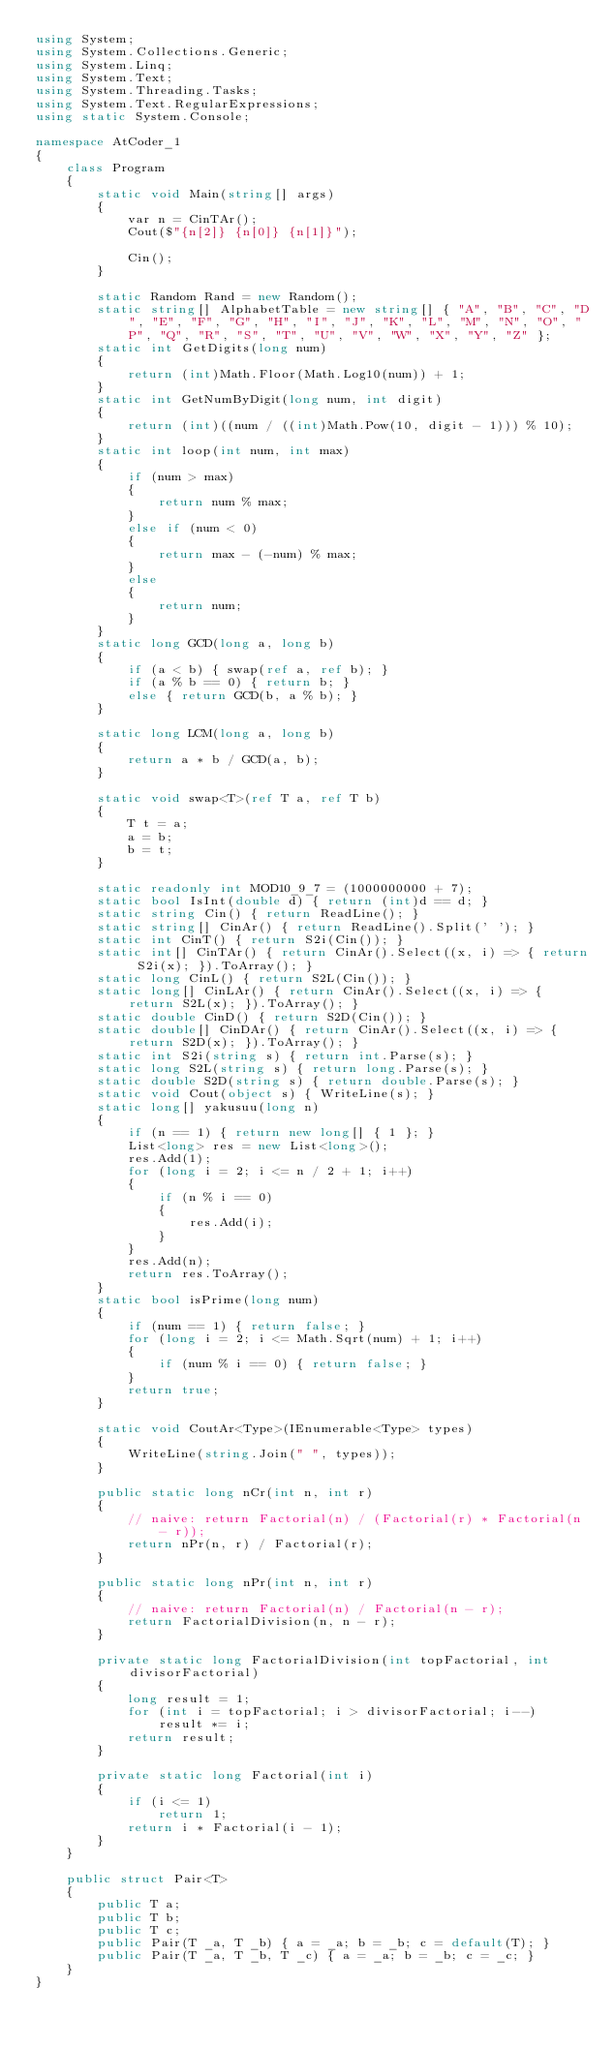<code> <loc_0><loc_0><loc_500><loc_500><_C#_>using System;
using System.Collections.Generic;
using System.Linq;
using System.Text;
using System.Threading.Tasks;
using System.Text.RegularExpressions;
using static System.Console;

namespace AtCoder_1
{
    class Program
    {
        static void Main(string[] args)
        {
            var n = CinTAr();
            Cout($"{n[2]} {n[0]} {n[1]}");

            Cin();
        }

        static Random Rand = new Random();
        static string[] AlphabetTable = new string[] { "A", "B", "C", "D", "E", "F", "G", "H", "I", "J", "K", "L", "M", "N", "O", "P", "Q", "R", "S", "T", "U", "V", "W", "X", "Y", "Z" };
        static int GetDigits(long num)
        {
            return (int)Math.Floor(Math.Log10(num)) + 1;
        }
        static int GetNumByDigit(long num, int digit)
        {
            return (int)((num / ((int)Math.Pow(10, digit - 1))) % 10);
        }
        static int loop(int num, int max)
        {
            if (num > max)
            {
                return num % max;
            }
            else if (num < 0)
            {
                return max - (-num) % max;
            }
            else
            {
                return num;
            }
        }
        static long GCD(long a, long b)
        {
            if (a < b) { swap(ref a, ref b); }
            if (a % b == 0) { return b; }
            else { return GCD(b, a % b); }
        }

        static long LCM(long a, long b)
        {
            return a * b / GCD(a, b);
        }

        static void swap<T>(ref T a, ref T b)
        {
            T t = a;
            a = b;
            b = t;
        }

        static readonly int MOD10_9_7 = (1000000000 + 7);
        static bool IsInt(double d) { return (int)d == d; }
        static string Cin() { return ReadLine(); }
        static string[] CinAr() { return ReadLine().Split(' '); }
        static int CinT() { return S2i(Cin()); }
        static int[] CinTAr() { return CinAr().Select((x, i) => { return S2i(x); }).ToArray(); }
        static long CinL() { return S2L(Cin()); }
        static long[] CinLAr() { return CinAr().Select((x, i) => { return S2L(x); }).ToArray(); }
        static double CinD() { return S2D(Cin()); }
        static double[] CinDAr() { return CinAr().Select((x, i) => { return S2D(x); }).ToArray(); }
        static int S2i(string s) { return int.Parse(s); }
        static long S2L(string s) { return long.Parse(s); }
        static double S2D(string s) { return double.Parse(s); }
        static void Cout(object s) { WriteLine(s); }
        static long[] yakusuu(long n)
        {
            if (n == 1) { return new long[] { 1 }; }
            List<long> res = new List<long>();
            res.Add(1);
            for (long i = 2; i <= n / 2 + 1; i++)
            {
                if (n % i == 0)
                {
                    res.Add(i);
                }
            }
            res.Add(n);
            return res.ToArray();
        }
        static bool isPrime(long num)
        {
            if (num == 1) { return false; }
            for (long i = 2; i <= Math.Sqrt(num) + 1; i++)
            {
                if (num % i == 0) { return false; }
            }
            return true;
        }

        static void CoutAr<Type>(IEnumerable<Type> types)
        {
            WriteLine(string.Join(" ", types));
        }

        public static long nCr(int n, int r)
        {
            // naive: return Factorial(n) / (Factorial(r) * Factorial(n - r));
            return nPr(n, r) / Factorial(r);
        }

        public static long nPr(int n, int r)
        {
            // naive: return Factorial(n) / Factorial(n - r);
            return FactorialDivision(n, n - r);
        }

        private static long FactorialDivision(int topFactorial, int divisorFactorial)
        {
            long result = 1;
            for (int i = topFactorial; i > divisorFactorial; i--)
                result *= i;
            return result;
        }

        private static long Factorial(int i)
        {
            if (i <= 1)
                return 1;
            return i * Factorial(i - 1);
        }
    }

    public struct Pair<T>
    {
        public T a;
        public T b;
        public T c;
        public Pair(T _a, T _b) { a = _a; b = _b; c = default(T); }
        public Pair(T _a, T _b, T _c) { a = _a; b = _b; c = _c; }
    }
}
</code> 